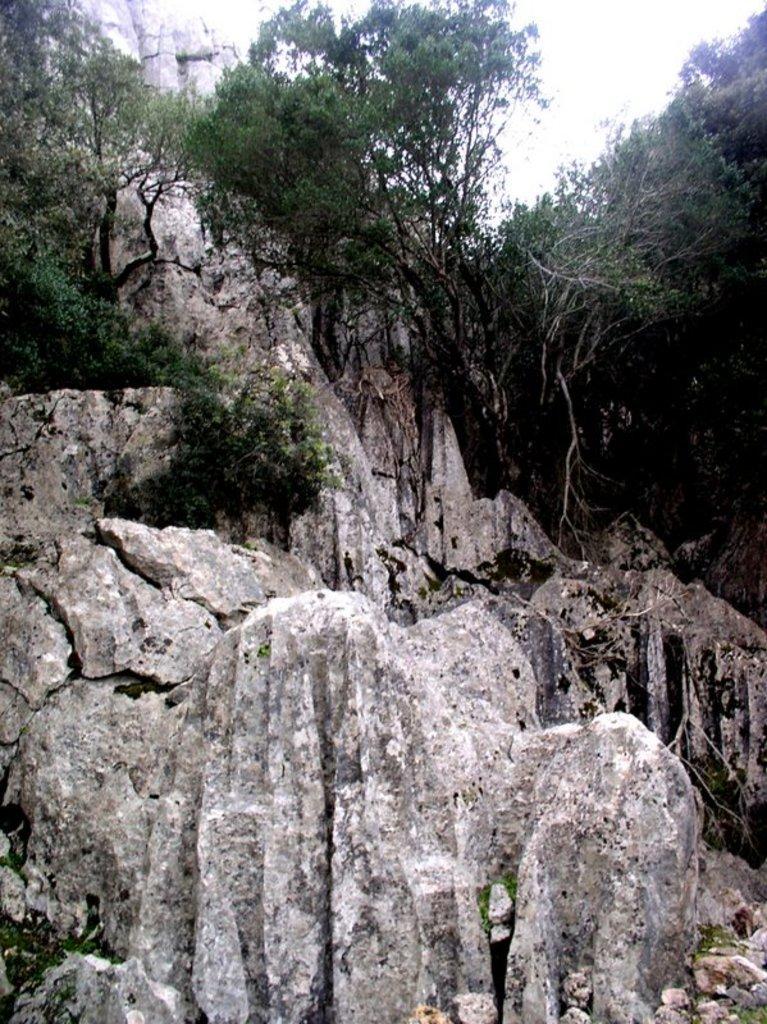Could you give a brief overview of what you see in this image? In this picture we can see mountains, trees, stones are present. At the top of the image sky is there. 